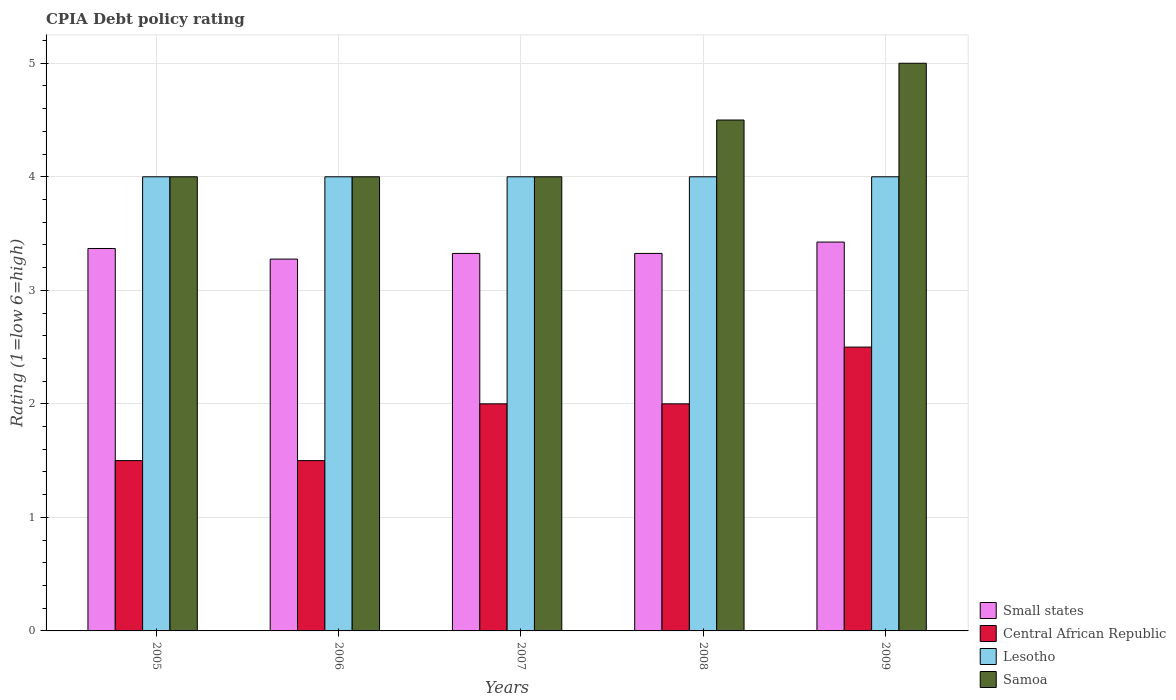How many different coloured bars are there?
Provide a succinct answer. 4. Are the number of bars per tick equal to the number of legend labels?
Offer a very short reply. Yes. How many bars are there on the 1st tick from the right?
Provide a succinct answer. 4. What is the label of the 3rd group of bars from the left?
Keep it short and to the point. 2007. What is the CPIA rating in Central African Republic in 2005?
Make the answer very short. 1.5. Across all years, what is the maximum CPIA rating in Central African Republic?
Your response must be concise. 2.5. Across all years, what is the minimum CPIA rating in Lesotho?
Offer a terse response. 4. What is the total CPIA rating in Lesotho in the graph?
Offer a terse response. 20. What is the difference between the CPIA rating in Central African Republic in 2005 and the CPIA rating in Lesotho in 2009?
Give a very brief answer. -2.5. In the year 2005, what is the difference between the CPIA rating in Central African Republic and CPIA rating in Small states?
Your response must be concise. -1.87. Is the CPIA rating in Central African Republic in 2005 less than that in 2007?
Your answer should be compact. Yes. What is the difference between the highest and the lowest CPIA rating in Small states?
Provide a succinct answer. 0.15. Is it the case that in every year, the sum of the CPIA rating in Central African Republic and CPIA rating in Samoa is greater than the sum of CPIA rating in Small states and CPIA rating in Lesotho?
Provide a short and direct response. No. What does the 1st bar from the left in 2008 represents?
Ensure brevity in your answer.  Small states. What does the 4th bar from the right in 2009 represents?
Ensure brevity in your answer.  Small states. How many bars are there?
Make the answer very short. 20. Are all the bars in the graph horizontal?
Make the answer very short. No. How many years are there in the graph?
Offer a very short reply. 5. Are the values on the major ticks of Y-axis written in scientific E-notation?
Give a very brief answer. No. Does the graph contain any zero values?
Your answer should be very brief. No. Does the graph contain grids?
Offer a very short reply. Yes. Where does the legend appear in the graph?
Your answer should be very brief. Bottom right. How are the legend labels stacked?
Offer a terse response. Vertical. What is the title of the graph?
Your answer should be very brief. CPIA Debt policy rating. Does "European Union" appear as one of the legend labels in the graph?
Your response must be concise. No. What is the Rating (1=low 6=high) in Small states in 2005?
Provide a short and direct response. 3.37. What is the Rating (1=low 6=high) in Central African Republic in 2005?
Keep it short and to the point. 1.5. What is the Rating (1=low 6=high) in Lesotho in 2005?
Give a very brief answer. 4. What is the Rating (1=low 6=high) of Small states in 2006?
Your answer should be compact. 3.27. What is the Rating (1=low 6=high) in Central African Republic in 2006?
Your answer should be very brief. 1.5. What is the Rating (1=low 6=high) of Samoa in 2006?
Give a very brief answer. 4. What is the Rating (1=low 6=high) in Small states in 2007?
Give a very brief answer. 3.33. What is the Rating (1=low 6=high) of Central African Republic in 2007?
Offer a very short reply. 2. What is the Rating (1=low 6=high) in Samoa in 2007?
Offer a terse response. 4. What is the Rating (1=low 6=high) in Small states in 2008?
Make the answer very short. 3.33. What is the Rating (1=low 6=high) of Small states in 2009?
Offer a very short reply. 3.42. What is the Rating (1=low 6=high) in Samoa in 2009?
Provide a succinct answer. 5. Across all years, what is the maximum Rating (1=low 6=high) of Small states?
Your answer should be very brief. 3.42. Across all years, what is the maximum Rating (1=low 6=high) of Central African Republic?
Provide a short and direct response. 2.5. Across all years, what is the maximum Rating (1=low 6=high) of Lesotho?
Keep it short and to the point. 4. Across all years, what is the maximum Rating (1=low 6=high) in Samoa?
Ensure brevity in your answer.  5. Across all years, what is the minimum Rating (1=low 6=high) in Small states?
Provide a short and direct response. 3.27. What is the total Rating (1=low 6=high) in Small states in the graph?
Offer a very short reply. 16.72. What is the difference between the Rating (1=low 6=high) of Small states in 2005 and that in 2006?
Your answer should be compact. 0.09. What is the difference between the Rating (1=low 6=high) in Central African Republic in 2005 and that in 2006?
Your answer should be compact. 0. What is the difference between the Rating (1=low 6=high) in Lesotho in 2005 and that in 2006?
Make the answer very short. 0. What is the difference between the Rating (1=low 6=high) in Small states in 2005 and that in 2007?
Give a very brief answer. 0.04. What is the difference between the Rating (1=low 6=high) of Central African Republic in 2005 and that in 2007?
Your response must be concise. -0.5. What is the difference between the Rating (1=low 6=high) in Samoa in 2005 and that in 2007?
Offer a terse response. 0. What is the difference between the Rating (1=low 6=high) in Small states in 2005 and that in 2008?
Your answer should be very brief. 0.04. What is the difference between the Rating (1=low 6=high) of Lesotho in 2005 and that in 2008?
Your response must be concise. 0. What is the difference between the Rating (1=low 6=high) in Samoa in 2005 and that in 2008?
Your response must be concise. -0.5. What is the difference between the Rating (1=low 6=high) in Small states in 2005 and that in 2009?
Your response must be concise. -0.06. What is the difference between the Rating (1=low 6=high) of Small states in 2006 and that in 2007?
Provide a succinct answer. -0.05. What is the difference between the Rating (1=low 6=high) of Central African Republic in 2006 and that in 2007?
Offer a very short reply. -0.5. What is the difference between the Rating (1=low 6=high) in Central African Republic in 2006 and that in 2008?
Keep it short and to the point. -0.5. What is the difference between the Rating (1=low 6=high) in Central African Republic in 2007 and that in 2008?
Make the answer very short. 0. What is the difference between the Rating (1=low 6=high) of Samoa in 2007 and that in 2008?
Give a very brief answer. -0.5. What is the difference between the Rating (1=low 6=high) of Samoa in 2007 and that in 2009?
Make the answer very short. -1. What is the difference between the Rating (1=low 6=high) in Small states in 2008 and that in 2009?
Your response must be concise. -0.1. What is the difference between the Rating (1=low 6=high) of Lesotho in 2008 and that in 2009?
Provide a succinct answer. 0. What is the difference between the Rating (1=low 6=high) in Samoa in 2008 and that in 2009?
Make the answer very short. -0.5. What is the difference between the Rating (1=low 6=high) of Small states in 2005 and the Rating (1=low 6=high) of Central African Republic in 2006?
Your answer should be very brief. 1.87. What is the difference between the Rating (1=low 6=high) of Small states in 2005 and the Rating (1=low 6=high) of Lesotho in 2006?
Your response must be concise. -0.63. What is the difference between the Rating (1=low 6=high) in Small states in 2005 and the Rating (1=low 6=high) in Samoa in 2006?
Keep it short and to the point. -0.63. What is the difference between the Rating (1=low 6=high) of Central African Republic in 2005 and the Rating (1=low 6=high) of Samoa in 2006?
Make the answer very short. -2.5. What is the difference between the Rating (1=low 6=high) of Lesotho in 2005 and the Rating (1=low 6=high) of Samoa in 2006?
Offer a terse response. 0. What is the difference between the Rating (1=low 6=high) in Small states in 2005 and the Rating (1=low 6=high) in Central African Republic in 2007?
Your response must be concise. 1.37. What is the difference between the Rating (1=low 6=high) in Small states in 2005 and the Rating (1=low 6=high) in Lesotho in 2007?
Ensure brevity in your answer.  -0.63. What is the difference between the Rating (1=low 6=high) in Small states in 2005 and the Rating (1=low 6=high) in Samoa in 2007?
Offer a very short reply. -0.63. What is the difference between the Rating (1=low 6=high) of Central African Republic in 2005 and the Rating (1=low 6=high) of Lesotho in 2007?
Keep it short and to the point. -2.5. What is the difference between the Rating (1=low 6=high) in Central African Republic in 2005 and the Rating (1=low 6=high) in Samoa in 2007?
Your answer should be compact. -2.5. What is the difference between the Rating (1=low 6=high) in Small states in 2005 and the Rating (1=low 6=high) in Central African Republic in 2008?
Provide a short and direct response. 1.37. What is the difference between the Rating (1=low 6=high) in Small states in 2005 and the Rating (1=low 6=high) in Lesotho in 2008?
Make the answer very short. -0.63. What is the difference between the Rating (1=low 6=high) of Small states in 2005 and the Rating (1=low 6=high) of Samoa in 2008?
Your response must be concise. -1.13. What is the difference between the Rating (1=low 6=high) in Central African Republic in 2005 and the Rating (1=low 6=high) in Lesotho in 2008?
Offer a very short reply. -2.5. What is the difference between the Rating (1=low 6=high) of Small states in 2005 and the Rating (1=low 6=high) of Central African Republic in 2009?
Your answer should be compact. 0.87. What is the difference between the Rating (1=low 6=high) of Small states in 2005 and the Rating (1=low 6=high) of Lesotho in 2009?
Provide a short and direct response. -0.63. What is the difference between the Rating (1=low 6=high) of Small states in 2005 and the Rating (1=low 6=high) of Samoa in 2009?
Keep it short and to the point. -1.63. What is the difference between the Rating (1=low 6=high) in Central African Republic in 2005 and the Rating (1=low 6=high) in Samoa in 2009?
Give a very brief answer. -3.5. What is the difference between the Rating (1=low 6=high) of Lesotho in 2005 and the Rating (1=low 6=high) of Samoa in 2009?
Make the answer very short. -1. What is the difference between the Rating (1=low 6=high) of Small states in 2006 and the Rating (1=low 6=high) of Central African Republic in 2007?
Provide a short and direct response. 1.27. What is the difference between the Rating (1=low 6=high) in Small states in 2006 and the Rating (1=low 6=high) in Lesotho in 2007?
Give a very brief answer. -0.72. What is the difference between the Rating (1=low 6=high) in Small states in 2006 and the Rating (1=low 6=high) in Samoa in 2007?
Your response must be concise. -0.72. What is the difference between the Rating (1=low 6=high) of Central African Republic in 2006 and the Rating (1=low 6=high) of Samoa in 2007?
Make the answer very short. -2.5. What is the difference between the Rating (1=low 6=high) of Lesotho in 2006 and the Rating (1=low 6=high) of Samoa in 2007?
Your answer should be very brief. 0. What is the difference between the Rating (1=low 6=high) in Small states in 2006 and the Rating (1=low 6=high) in Central African Republic in 2008?
Your response must be concise. 1.27. What is the difference between the Rating (1=low 6=high) in Small states in 2006 and the Rating (1=low 6=high) in Lesotho in 2008?
Make the answer very short. -0.72. What is the difference between the Rating (1=low 6=high) of Small states in 2006 and the Rating (1=low 6=high) of Samoa in 2008?
Offer a very short reply. -1.23. What is the difference between the Rating (1=low 6=high) in Central African Republic in 2006 and the Rating (1=low 6=high) in Samoa in 2008?
Your answer should be very brief. -3. What is the difference between the Rating (1=low 6=high) in Lesotho in 2006 and the Rating (1=low 6=high) in Samoa in 2008?
Offer a very short reply. -0.5. What is the difference between the Rating (1=low 6=high) in Small states in 2006 and the Rating (1=low 6=high) in Central African Republic in 2009?
Offer a very short reply. 0.78. What is the difference between the Rating (1=low 6=high) in Small states in 2006 and the Rating (1=low 6=high) in Lesotho in 2009?
Make the answer very short. -0.72. What is the difference between the Rating (1=low 6=high) in Small states in 2006 and the Rating (1=low 6=high) in Samoa in 2009?
Your answer should be compact. -1.73. What is the difference between the Rating (1=low 6=high) in Small states in 2007 and the Rating (1=low 6=high) in Central African Republic in 2008?
Make the answer very short. 1.32. What is the difference between the Rating (1=low 6=high) in Small states in 2007 and the Rating (1=low 6=high) in Lesotho in 2008?
Provide a short and direct response. -0.68. What is the difference between the Rating (1=low 6=high) in Small states in 2007 and the Rating (1=low 6=high) in Samoa in 2008?
Provide a succinct answer. -1.18. What is the difference between the Rating (1=low 6=high) in Central African Republic in 2007 and the Rating (1=low 6=high) in Lesotho in 2008?
Give a very brief answer. -2. What is the difference between the Rating (1=low 6=high) of Small states in 2007 and the Rating (1=low 6=high) of Central African Republic in 2009?
Your answer should be very brief. 0.82. What is the difference between the Rating (1=low 6=high) in Small states in 2007 and the Rating (1=low 6=high) in Lesotho in 2009?
Make the answer very short. -0.68. What is the difference between the Rating (1=low 6=high) of Small states in 2007 and the Rating (1=low 6=high) of Samoa in 2009?
Provide a short and direct response. -1.68. What is the difference between the Rating (1=low 6=high) of Central African Republic in 2007 and the Rating (1=low 6=high) of Lesotho in 2009?
Ensure brevity in your answer.  -2. What is the difference between the Rating (1=low 6=high) in Lesotho in 2007 and the Rating (1=low 6=high) in Samoa in 2009?
Keep it short and to the point. -1. What is the difference between the Rating (1=low 6=high) in Small states in 2008 and the Rating (1=low 6=high) in Central African Republic in 2009?
Your response must be concise. 0.82. What is the difference between the Rating (1=low 6=high) in Small states in 2008 and the Rating (1=low 6=high) in Lesotho in 2009?
Your answer should be compact. -0.68. What is the difference between the Rating (1=low 6=high) of Small states in 2008 and the Rating (1=low 6=high) of Samoa in 2009?
Keep it short and to the point. -1.68. What is the average Rating (1=low 6=high) of Small states per year?
Ensure brevity in your answer.  3.34. In the year 2005, what is the difference between the Rating (1=low 6=high) in Small states and Rating (1=low 6=high) in Central African Republic?
Provide a short and direct response. 1.87. In the year 2005, what is the difference between the Rating (1=low 6=high) of Small states and Rating (1=low 6=high) of Lesotho?
Make the answer very short. -0.63. In the year 2005, what is the difference between the Rating (1=low 6=high) of Small states and Rating (1=low 6=high) of Samoa?
Ensure brevity in your answer.  -0.63. In the year 2005, what is the difference between the Rating (1=low 6=high) in Central African Republic and Rating (1=low 6=high) in Lesotho?
Give a very brief answer. -2.5. In the year 2005, what is the difference between the Rating (1=low 6=high) of Central African Republic and Rating (1=low 6=high) of Samoa?
Make the answer very short. -2.5. In the year 2005, what is the difference between the Rating (1=low 6=high) of Lesotho and Rating (1=low 6=high) of Samoa?
Keep it short and to the point. 0. In the year 2006, what is the difference between the Rating (1=low 6=high) in Small states and Rating (1=low 6=high) in Central African Republic?
Provide a short and direct response. 1.77. In the year 2006, what is the difference between the Rating (1=low 6=high) in Small states and Rating (1=low 6=high) in Lesotho?
Provide a succinct answer. -0.72. In the year 2006, what is the difference between the Rating (1=low 6=high) of Small states and Rating (1=low 6=high) of Samoa?
Provide a short and direct response. -0.72. In the year 2006, what is the difference between the Rating (1=low 6=high) of Central African Republic and Rating (1=low 6=high) of Samoa?
Your answer should be compact. -2.5. In the year 2006, what is the difference between the Rating (1=low 6=high) of Lesotho and Rating (1=low 6=high) of Samoa?
Your answer should be compact. 0. In the year 2007, what is the difference between the Rating (1=low 6=high) in Small states and Rating (1=low 6=high) in Central African Republic?
Offer a terse response. 1.32. In the year 2007, what is the difference between the Rating (1=low 6=high) of Small states and Rating (1=low 6=high) of Lesotho?
Offer a very short reply. -0.68. In the year 2007, what is the difference between the Rating (1=low 6=high) in Small states and Rating (1=low 6=high) in Samoa?
Offer a terse response. -0.68. In the year 2007, what is the difference between the Rating (1=low 6=high) in Central African Republic and Rating (1=low 6=high) in Samoa?
Ensure brevity in your answer.  -2. In the year 2007, what is the difference between the Rating (1=low 6=high) of Lesotho and Rating (1=low 6=high) of Samoa?
Offer a terse response. 0. In the year 2008, what is the difference between the Rating (1=low 6=high) of Small states and Rating (1=low 6=high) of Central African Republic?
Give a very brief answer. 1.32. In the year 2008, what is the difference between the Rating (1=low 6=high) in Small states and Rating (1=low 6=high) in Lesotho?
Offer a very short reply. -0.68. In the year 2008, what is the difference between the Rating (1=low 6=high) in Small states and Rating (1=low 6=high) in Samoa?
Your answer should be compact. -1.18. In the year 2008, what is the difference between the Rating (1=low 6=high) of Central African Republic and Rating (1=low 6=high) of Lesotho?
Your answer should be very brief. -2. In the year 2008, what is the difference between the Rating (1=low 6=high) in Central African Republic and Rating (1=low 6=high) in Samoa?
Your answer should be compact. -2.5. In the year 2008, what is the difference between the Rating (1=low 6=high) in Lesotho and Rating (1=low 6=high) in Samoa?
Offer a terse response. -0.5. In the year 2009, what is the difference between the Rating (1=low 6=high) of Small states and Rating (1=low 6=high) of Central African Republic?
Keep it short and to the point. 0.93. In the year 2009, what is the difference between the Rating (1=low 6=high) in Small states and Rating (1=low 6=high) in Lesotho?
Your response must be concise. -0.57. In the year 2009, what is the difference between the Rating (1=low 6=high) of Small states and Rating (1=low 6=high) of Samoa?
Your answer should be very brief. -1.57. In the year 2009, what is the difference between the Rating (1=low 6=high) in Lesotho and Rating (1=low 6=high) in Samoa?
Keep it short and to the point. -1. What is the ratio of the Rating (1=low 6=high) of Small states in 2005 to that in 2006?
Provide a succinct answer. 1.03. What is the ratio of the Rating (1=low 6=high) in Central African Republic in 2005 to that in 2006?
Make the answer very short. 1. What is the ratio of the Rating (1=low 6=high) in Lesotho in 2005 to that in 2006?
Your answer should be very brief. 1. What is the ratio of the Rating (1=low 6=high) of Small states in 2005 to that in 2007?
Ensure brevity in your answer.  1.01. What is the ratio of the Rating (1=low 6=high) of Samoa in 2005 to that in 2007?
Offer a terse response. 1. What is the ratio of the Rating (1=low 6=high) in Small states in 2005 to that in 2008?
Your answer should be very brief. 1.01. What is the ratio of the Rating (1=low 6=high) of Samoa in 2005 to that in 2008?
Your response must be concise. 0.89. What is the ratio of the Rating (1=low 6=high) in Small states in 2005 to that in 2009?
Your answer should be compact. 0.98. What is the ratio of the Rating (1=low 6=high) of Lesotho in 2005 to that in 2009?
Keep it short and to the point. 1. What is the ratio of the Rating (1=low 6=high) in Samoa in 2005 to that in 2009?
Your response must be concise. 0.8. What is the ratio of the Rating (1=low 6=high) in Central African Republic in 2006 to that in 2007?
Provide a short and direct response. 0.75. What is the ratio of the Rating (1=low 6=high) of Samoa in 2006 to that in 2007?
Your answer should be compact. 1. What is the ratio of the Rating (1=low 6=high) of Central African Republic in 2006 to that in 2008?
Offer a very short reply. 0.75. What is the ratio of the Rating (1=low 6=high) of Small states in 2006 to that in 2009?
Offer a terse response. 0.96. What is the ratio of the Rating (1=low 6=high) in Lesotho in 2007 to that in 2008?
Offer a very short reply. 1. What is the ratio of the Rating (1=low 6=high) of Samoa in 2007 to that in 2008?
Offer a terse response. 0.89. What is the ratio of the Rating (1=low 6=high) of Small states in 2007 to that in 2009?
Your response must be concise. 0.97. What is the ratio of the Rating (1=low 6=high) in Lesotho in 2007 to that in 2009?
Offer a terse response. 1. What is the ratio of the Rating (1=low 6=high) in Samoa in 2007 to that in 2009?
Your response must be concise. 0.8. What is the ratio of the Rating (1=low 6=high) of Small states in 2008 to that in 2009?
Your response must be concise. 0.97. What is the ratio of the Rating (1=low 6=high) in Central African Republic in 2008 to that in 2009?
Your answer should be very brief. 0.8. What is the ratio of the Rating (1=low 6=high) in Samoa in 2008 to that in 2009?
Your response must be concise. 0.9. What is the difference between the highest and the second highest Rating (1=low 6=high) in Small states?
Make the answer very short. 0.06. What is the difference between the highest and the second highest Rating (1=low 6=high) in Central African Republic?
Provide a succinct answer. 0.5. What is the difference between the highest and the lowest Rating (1=low 6=high) in Small states?
Provide a short and direct response. 0.15. What is the difference between the highest and the lowest Rating (1=low 6=high) of Lesotho?
Your response must be concise. 0. What is the difference between the highest and the lowest Rating (1=low 6=high) in Samoa?
Your answer should be compact. 1. 